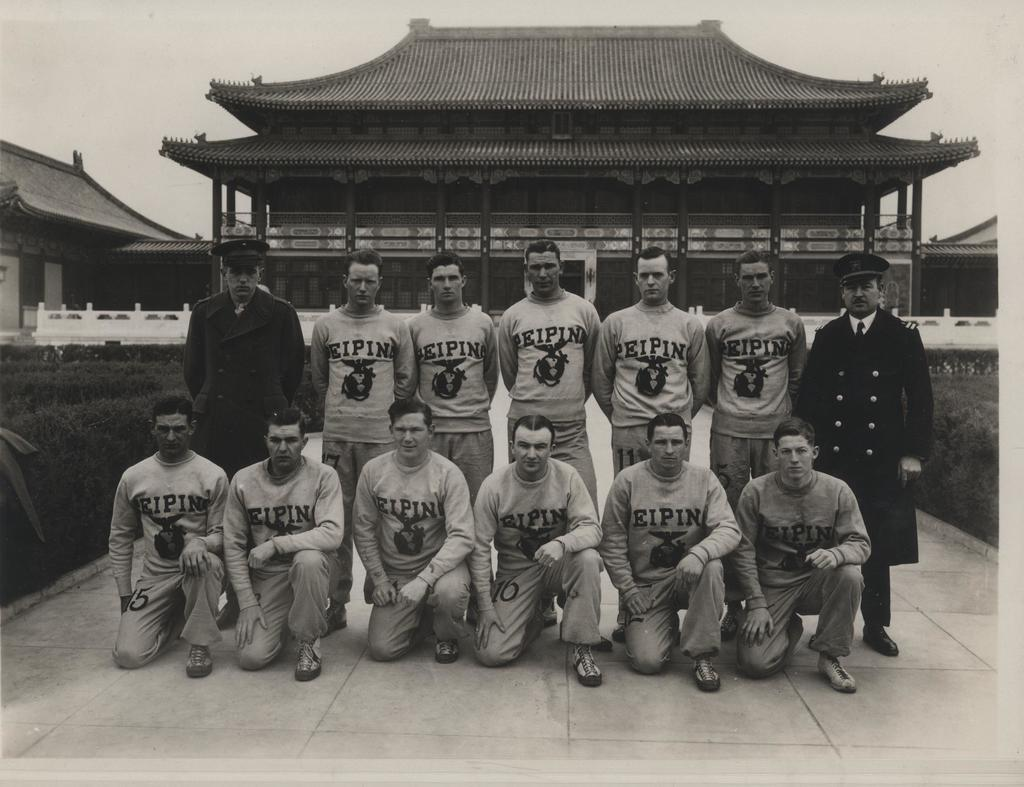<image>
Describe the image concisely. A team photo of Eipin players with an oriental house in the background. 